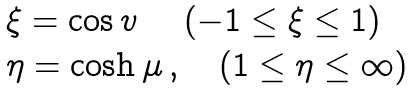Convert formula to latex. <formula><loc_0><loc_0><loc_500><loc_500>\begin{array} { l } \xi = \cos v \ \quad ( - 1 \leq \xi \leq 1 ) \\ \eta = \cosh \mu \, , \quad ( 1 \leq \eta \leq \infty ) \end{array}</formula> 